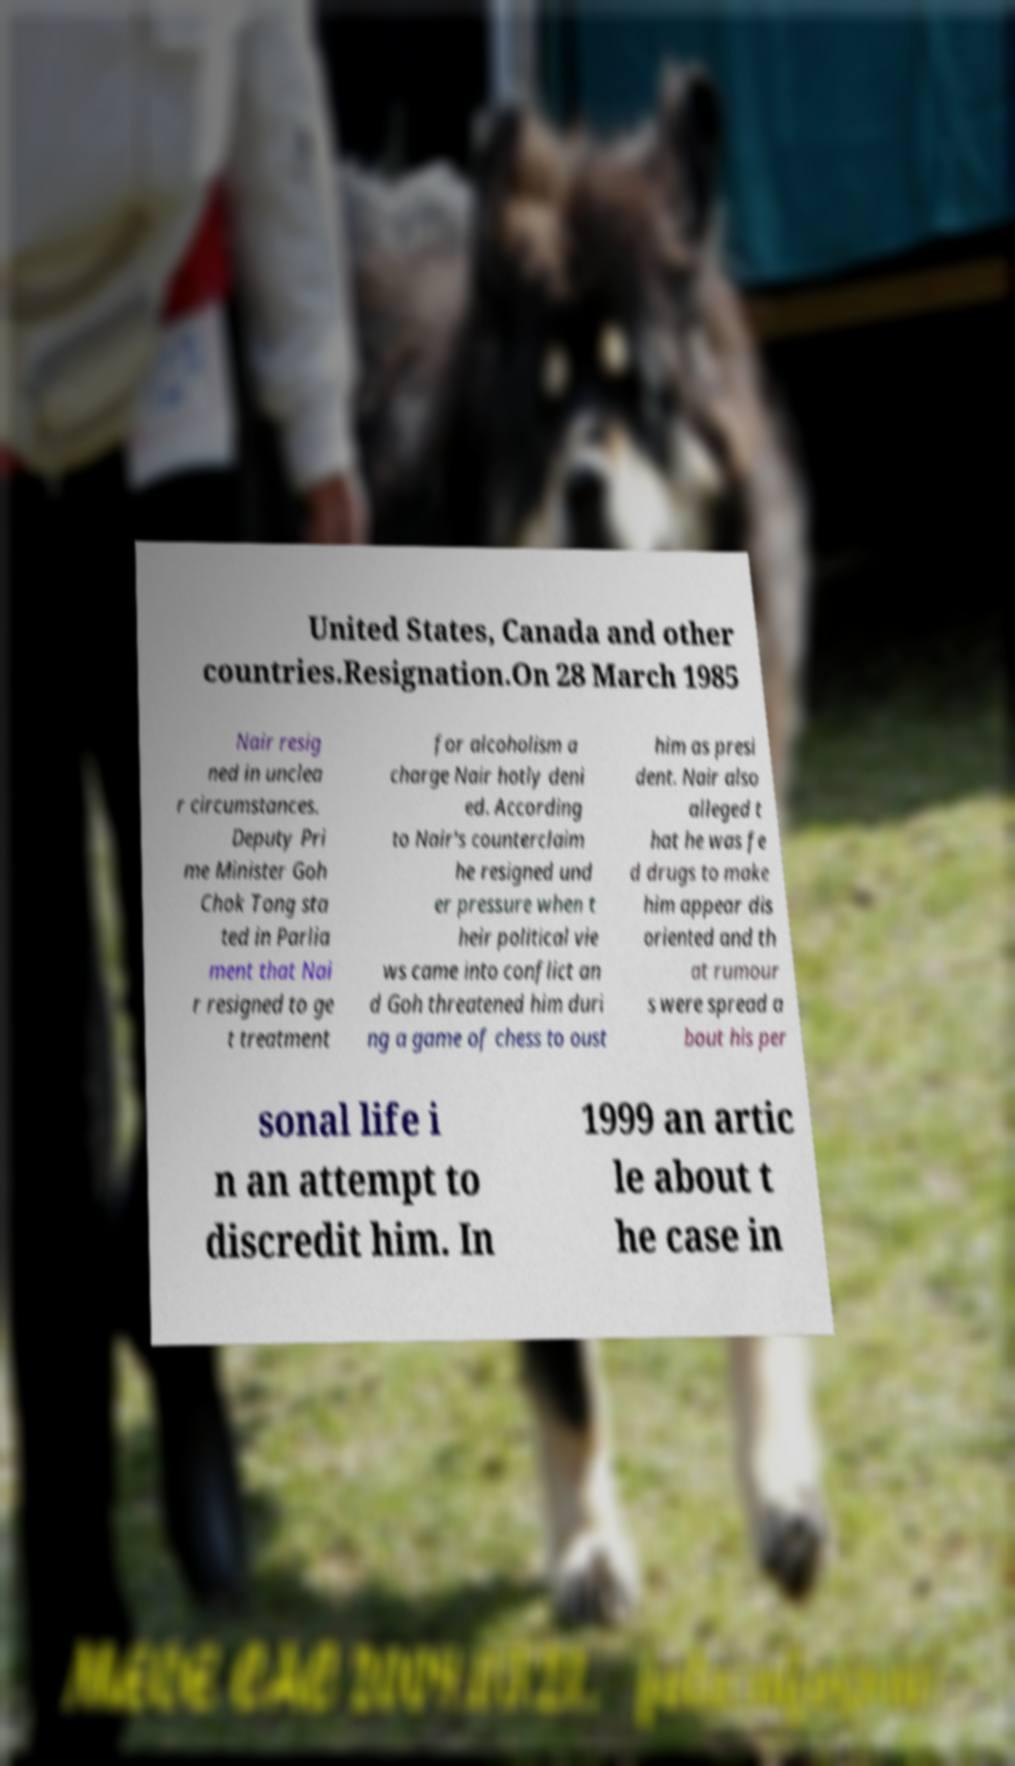Can you read and provide the text displayed in the image?This photo seems to have some interesting text. Can you extract and type it out for me? United States, Canada and other countries.Resignation.On 28 March 1985 Nair resig ned in unclea r circumstances. Deputy Pri me Minister Goh Chok Tong sta ted in Parlia ment that Nai r resigned to ge t treatment for alcoholism a charge Nair hotly deni ed. According to Nair's counterclaim he resigned und er pressure when t heir political vie ws came into conflict an d Goh threatened him duri ng a game of chess to oust him as presi dent. Nair also alleged t hat he was fe d drugs to make him appear dis oriented and th at rumour s were spread a bout his per sonal life i n an attempt to discredit him. In 1999 an artic le about t he case in 